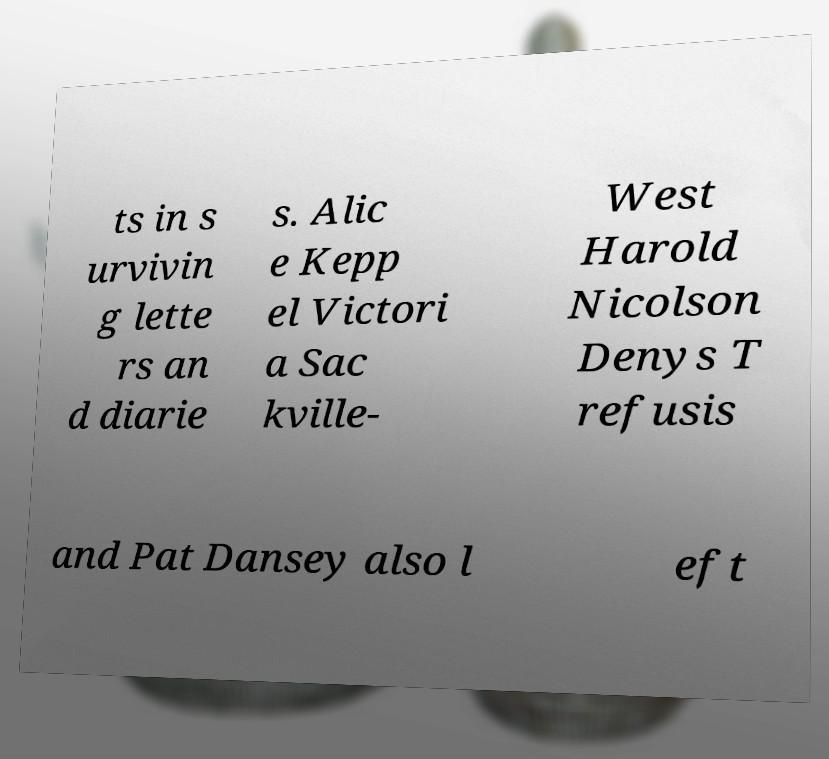For documentation purposes, I need the text within this image transcribed. Could you provide that? ts in s urvivin g lette rs an d diarie s. Alic e Kepp el Victori a Sac kville- West Harold Nicolson Denys T refusis and Pat Dansey also l eft 